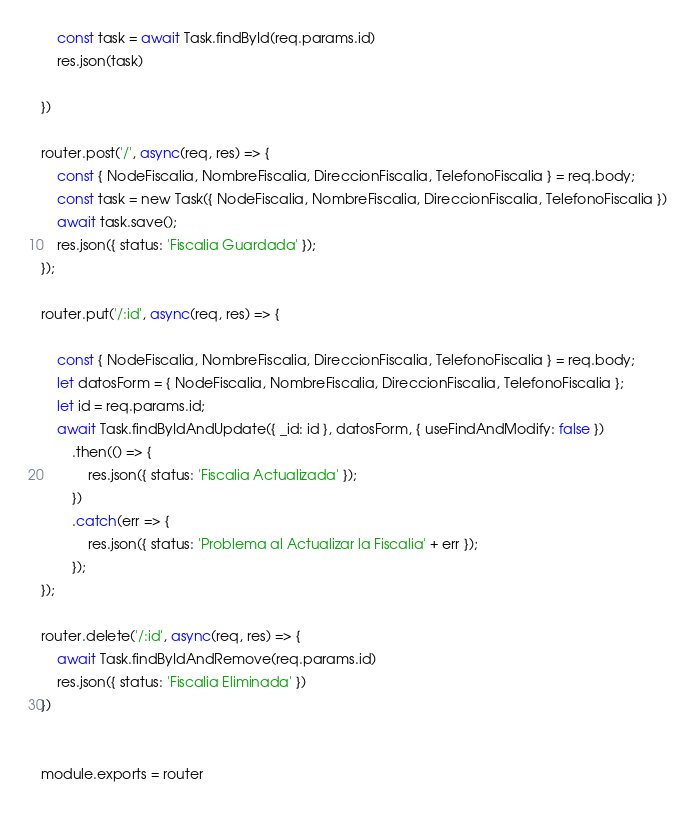Convert code to text. <code><loc_0><loc_0><loc_500><loc_500><_JavaScript_>    const task = await Task.findById(req.params.id)
    res.json(task)

})

router.post('/', async(req, res) => {
    const { NodeFiscalia, NombreFiscalia, DireccionFiscalia, TelefonoFiscalia } = req.body;
    const task = new Task({ NodeFiscalia, NombreFiscalia, DireccionFiscalia, TelefonoFiscalia })
    await task.save();
    res.json({ status: 'Fiscalia Guardada' });
});

router.put('/:id', async(req, res) => {

    const { NodeFiscalia, NombreFiscalia, DireccionFiscalia, TelefonoFiscalia } = req.body;
    let datosForm = { NodeFiscalia, NombreFiscalia, DireccionFiscalia, TelefonoFiscalia };
    let id = req.params.id;
    await Task.findByIdAndUpdate({ _id: id }, datosForm, { useFindAndModify: false })
        .then(() => {
            res.json({ status: 'Fiscalia Actualizada' });
        })
        .catch(err => {
            res.json({ status: 'Problema al Actualizar la Fiscalia' + err });
        });
});

router.delete('/:id', async(req, res) => {
    await Task.findByIdAndRemove(req.params.id)
    res.json({ status: 'Fiscalia Eliminada' })
})


module.exports = router</code> 